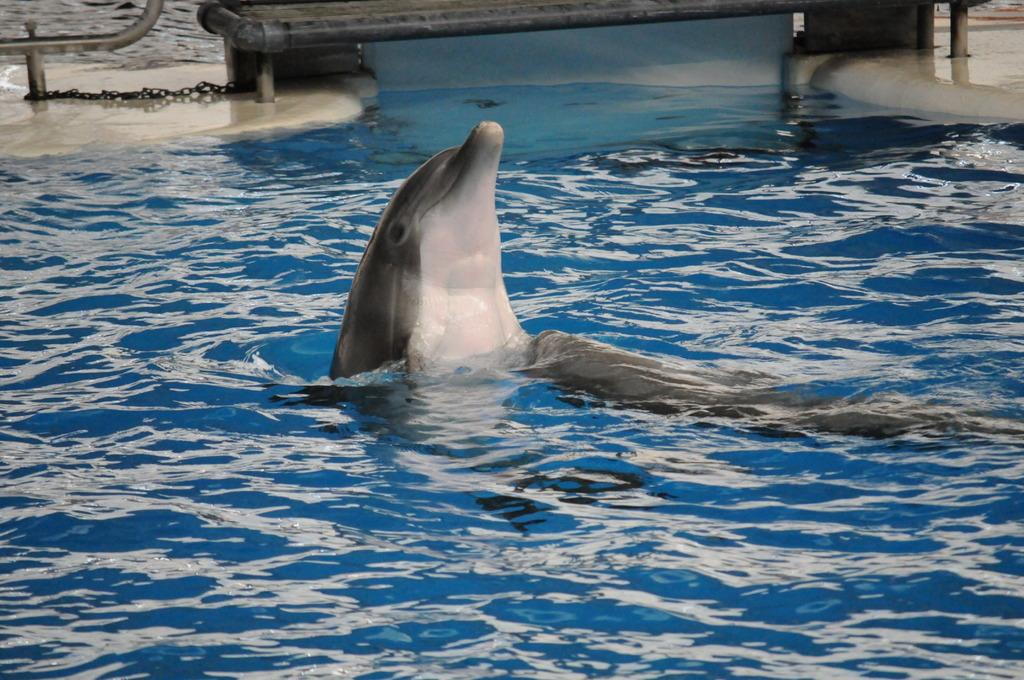What is present in the image? There is water visible in the image, and a dolphin is in the water. Can you describe the dolphin in the image? The dolphin is swimming in the water. What type of trees can be seen in the image? There are no trees present in the image; it features water and a dolphin. How does the spade help the dolphin in the image? There is no spade or any tool present in the image, and the dolphin does not require assistance from a spade. 